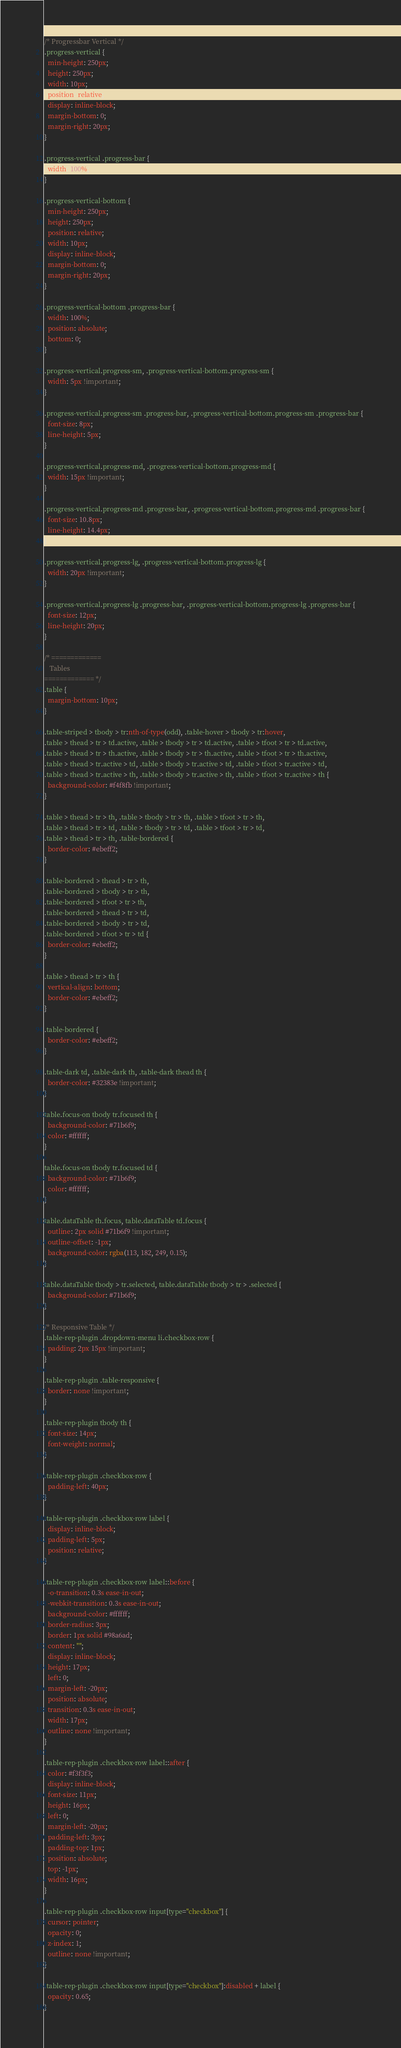<code> <loc_0><loc_0><loc_500><loc_500><_CSS_>/* Progressbar Vertical */
.progress-vertical {
  min-height: 250px;
  height: 250px;
  width: 10px;
  position: relative;
  display: inline-block;
  margin-bottom: 0;
  margin-right: 20px;
}

.progress-vertical .progress-bar {
  width: 100%;
}

.progress-vertical-bottom {
  min-height: 250px;
  height: 250px;
  position: relative;
  width: 10px;
  display: inline-block;
  margin-bottom: 0;
  margin-right: 20px;
}

.progress-vertical-bottom .progress-bar {
  width: 100%;
  position: absolute;
  bottom: 0;
}

.progress-vertical.progress-sm, .progress-vertical-bottom.progress-sm {
  width: 5px !important;
}

.progress-vertical.progress-sm .progress-bar, .progress-vertical-bottom.progress-sm .progress-bar {
  font-size: 8px;
  line-height: 5px;
}

.progress-vertical.progress-md, .progress-vertical-bottom.progress-md {
  width: 15px !important;
}

.progress-vertical.progress-md .progress-bar, .progress-vertical-bottom.progress-md .progress-bar {
  font-size: 10.8px;
  line-height: 14.4px;
}

.progress-vertical.progress-lg, .progress-vertical-bottom.progress-lg {
  width: 20px !important;
}

.progress-vertical.progress-lg .progress-bar, .progress-vertical-bottom.progress-lg .progress-bar {
  font-size: 12px;
  line-height: 20px;
}

/* =============
   Tables
============= */
.table {
  margin-bottom: 10px;
}

.table-striped > tbody > tr:nth-of-type(odd), .table-hover > tbody > tr:hover,
.table > thead > tr > td.active, .table > tbody > tr > td.active, .table > tfoot > tr > td.active,
.table > thead > tr > th.active, .table > tbody > tr > th.active, .table > tfoot > tr > th.active,
.table > thead > tr.active > td, .table > tbody > tr.active > td, .table > tfoot > tr.active > td,
.table > thead > tr.active > th, .table > tbody > tr.active > th, .table > tfoot > tr.active > th {
  background-color: #f4f8fb !important;
}

.table > thead > tr > th, .table > tbody > tr > th, .table > tfoot > tr > th,
.table > thead > tr > td, .table > tbody > tr > td, .table > tfoot > tr > td,
.table > thead > tr > th, .table-bordered {
  border-color: #ebeff2;
}

.table-bordered > thead > tr > th,
.table-bordered > tbody > tr > th,
.table-bordered > tfoot > tr > th,
.table-bordered > thead > tr > td,
.table-bordered > tbody > tr > td,
.table-bordered > tfoot > tr > td {
  border-color: #ebeff2;
}

.table > thead > tr > th {
  vertical-align: bottom;
  border-color: #ebeff2;
}

.table-bordered {
  border-color: #ebeff2;
}

.table-dark td, .table-dark th, .table-dark thead th {
  border-color: #32383e !important;
}

table.focus-on tbody tr.focused th {
  background-color: #71b6f9;
  color: #ffffff;
}

table.focus-on tbody tr.focused td {
  background-color: #71b6f9;
  color: #ffffff;
}

table.dataTable th.focus, table.dataTable td.focus {
  outline: 2px solid #71b6f9 !important;
  outline-offset: -1px;
  background-color: rgba(113, 182, 249, 0.15);
}

table.dataTable tbody > tr.selected, table.dataTable tbody > tr > .selected {
  background-color: #71b6f9;
}

/* Responsive Table */
.table-rep-plugin .dropdown-menu li.checkbox-row {
  padding: 2px 15px !important;
}

.table-rep-plugin .table-responsive {
  border: none !important;
}

.table-rep-plugin tbody th {
  font-size: 14px;
  font-weight: normal;
}

.table-rep-plugin .checkbox-row {
  padding-left: 40px;
}

.table-rep-plugin .checkbox-row label {
  display: inline-block;
  padding-left: 5px;
  position: relative;
}

.table-rep-plugin .checkbox-row label::before {
  -o-transition: 0.3s ease-in-out;
  -webkit-transition: 0.3s ease-in-out;
  background-color: #ffffff;
  border-radius: 3px;
  border: 1px solid #98a6ad;
  content: "";
  display: inline-block;
  height: 17px;
  left: 0;
  margin-left: -20px;
  position: absolute;
  transition: 0.3s ease-in-out;
  width: 17px;
  outline: none !important;
}

.table-rep-plugin .checkbox-row label::after {
  color: #f3f3f3;
  display: inline-block;
  font-size: 11px;
  height: 16px;
  left: 0;
  margin-left: -20px;
  padding-left: 3px;
  padding-top: 1px;
  position: absolute;
  top: -1px;
  width: 16px;
}

.table-rep-plugin .checkbox-row input[type="checkbox"] {
  cursor: pointer;
  opacity: 0;
  z-index: 1;
  outline: none !important;
}

.table-rep-plugin .checkbox-row input[type="checkbox"]:disabled + label {
  opacity: 0.65;
}
</code> 